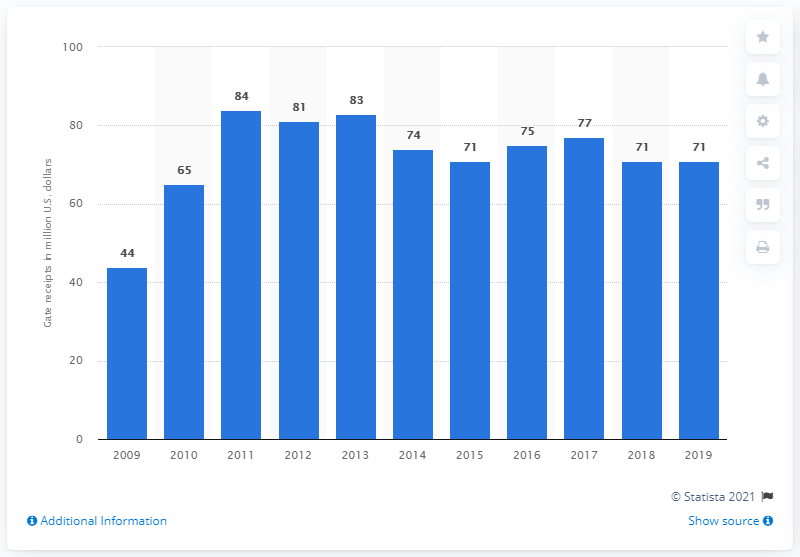Mention a couple of crucial points in this snapshot. The gate receipts of the Texas Rangers in 2019 were 71 dollars. 